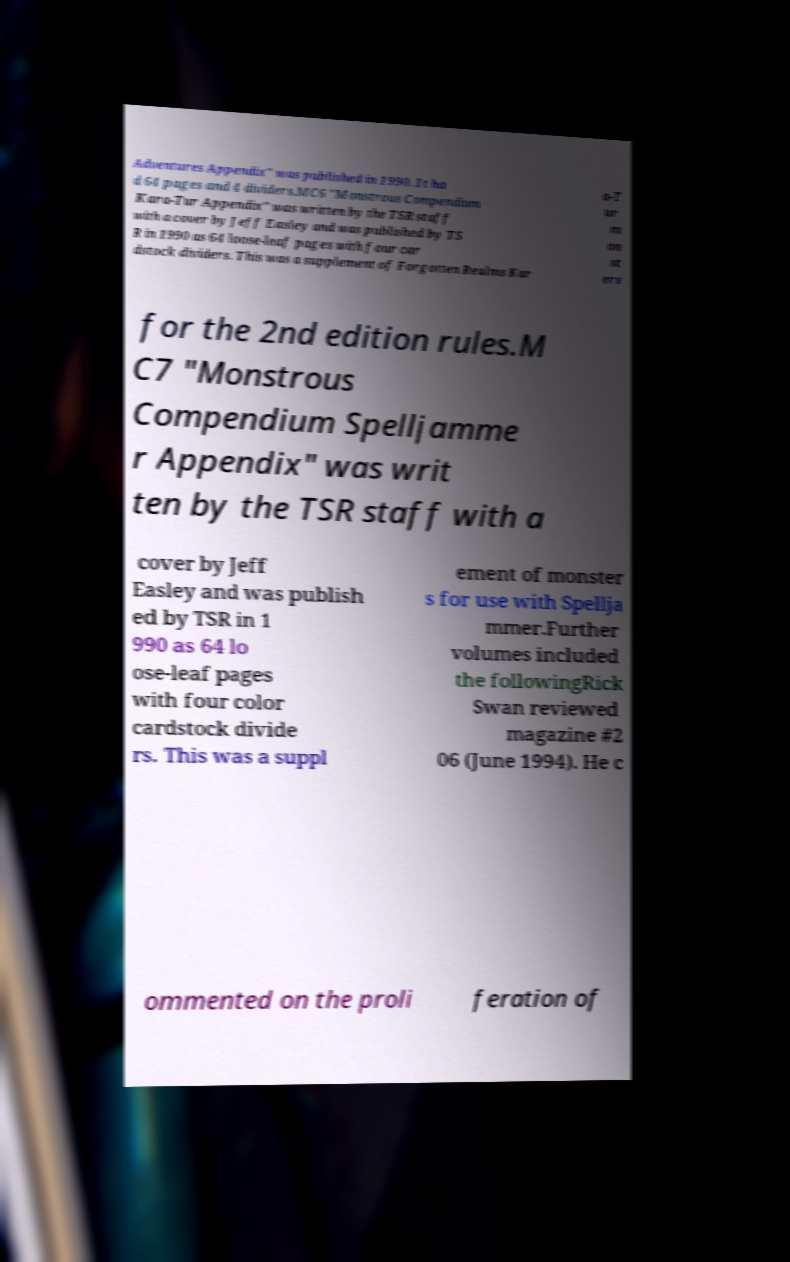Could you assist in decoding the text presented in this image and type it out clearly? Adventures Appendix" was published in 1990. It ha d 64 pages and 4 dividers.MC6 "Monstrous Compendium Kara-Tur Appendix" was written by the TSR staff with a cover by Jeff Easley and was published by TS R in 1990 as 64 loose-leaf pages with four car dstock dividers. This was a supplement of Forgotten Realms Kar a-T ur m on st ers for the 2nd edition rules.M C7 "Monstrous Compendium Spelljamme r Appendix" was writ ten by the TSR staff with a cover by Jeff Easley and was publish ed by TSR in 1 990 as 64 lo ose-leaf pages with four color cardstock divide rs. This was a suppl ement of monster s for use with Spellja mmer.Further volumes included the followingRick Swan reviewed magazine #2 06 (June 1994). He c ommented on the proli feration of 